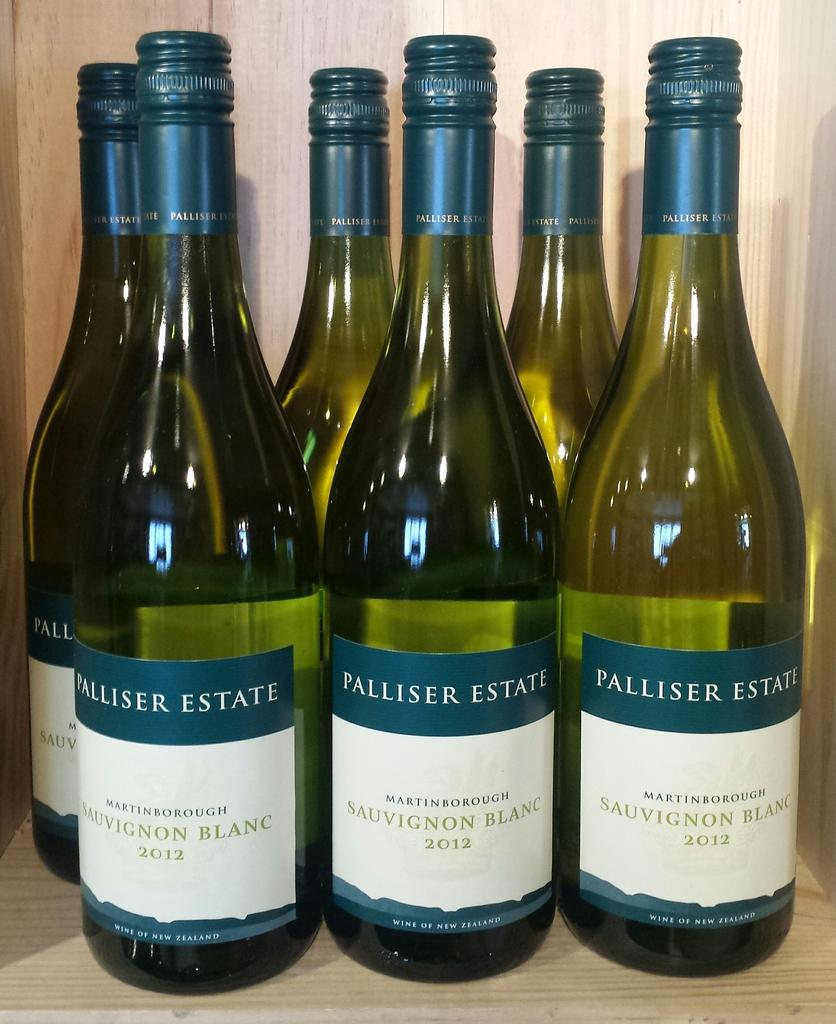<image>
Summarize the visual content of the image. Bottles of Palliser Estate are lined up in a wood box. 